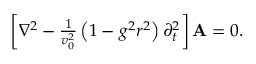<formula> <loc_0><loc_0><loc_500><loc_500>\begin{array} { r } { \left [ \nabla ^ { 2 } - \frac { 1 } { v _ { 0 } ^ { 2 } } \left ( 1 - g ^ { 2 } r ^ { 2 } \right ) \partial _ { t } ^ { 2 } \right ] { A } = 0 . } \end{array}</formula> 